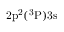<formula> <loc_0><loc_0><loc_500><loc_500>2 p ^ { 2 } ( ^ { 3 } P ) 3 s</formula> 